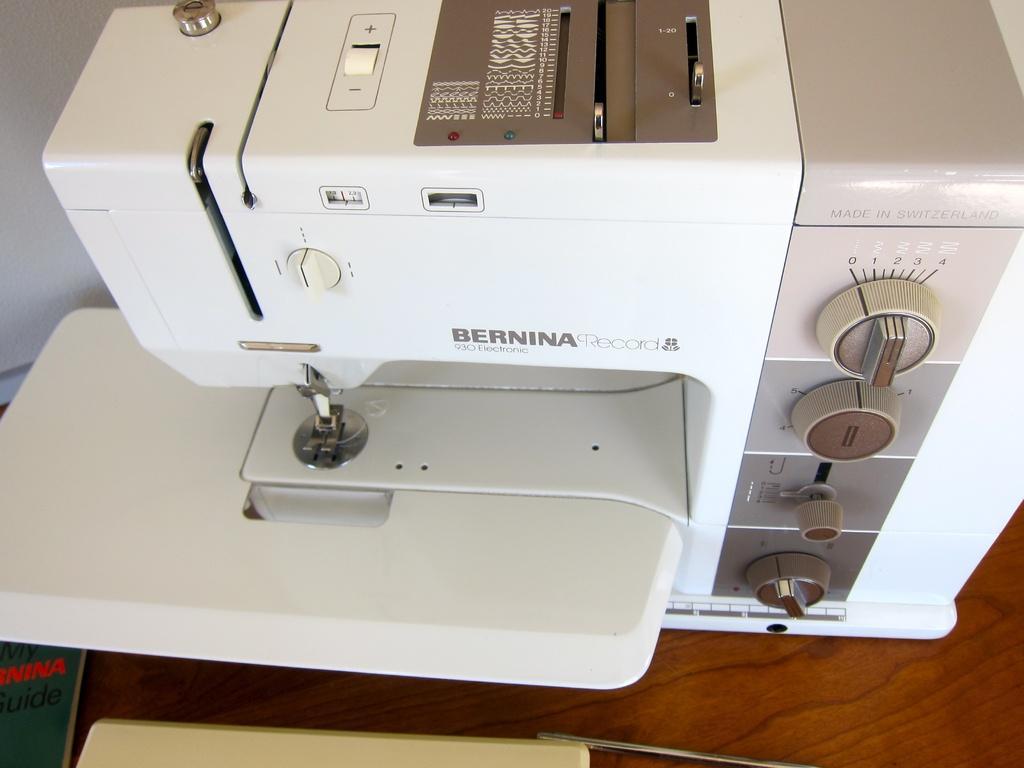Could you give a brief overview of what you see in this image? In this image, I can see a sewing machine, which is white in color. These are the regulators and a needle, which are attached to the sewing machine. I can see few objects placed on the wooden board. 